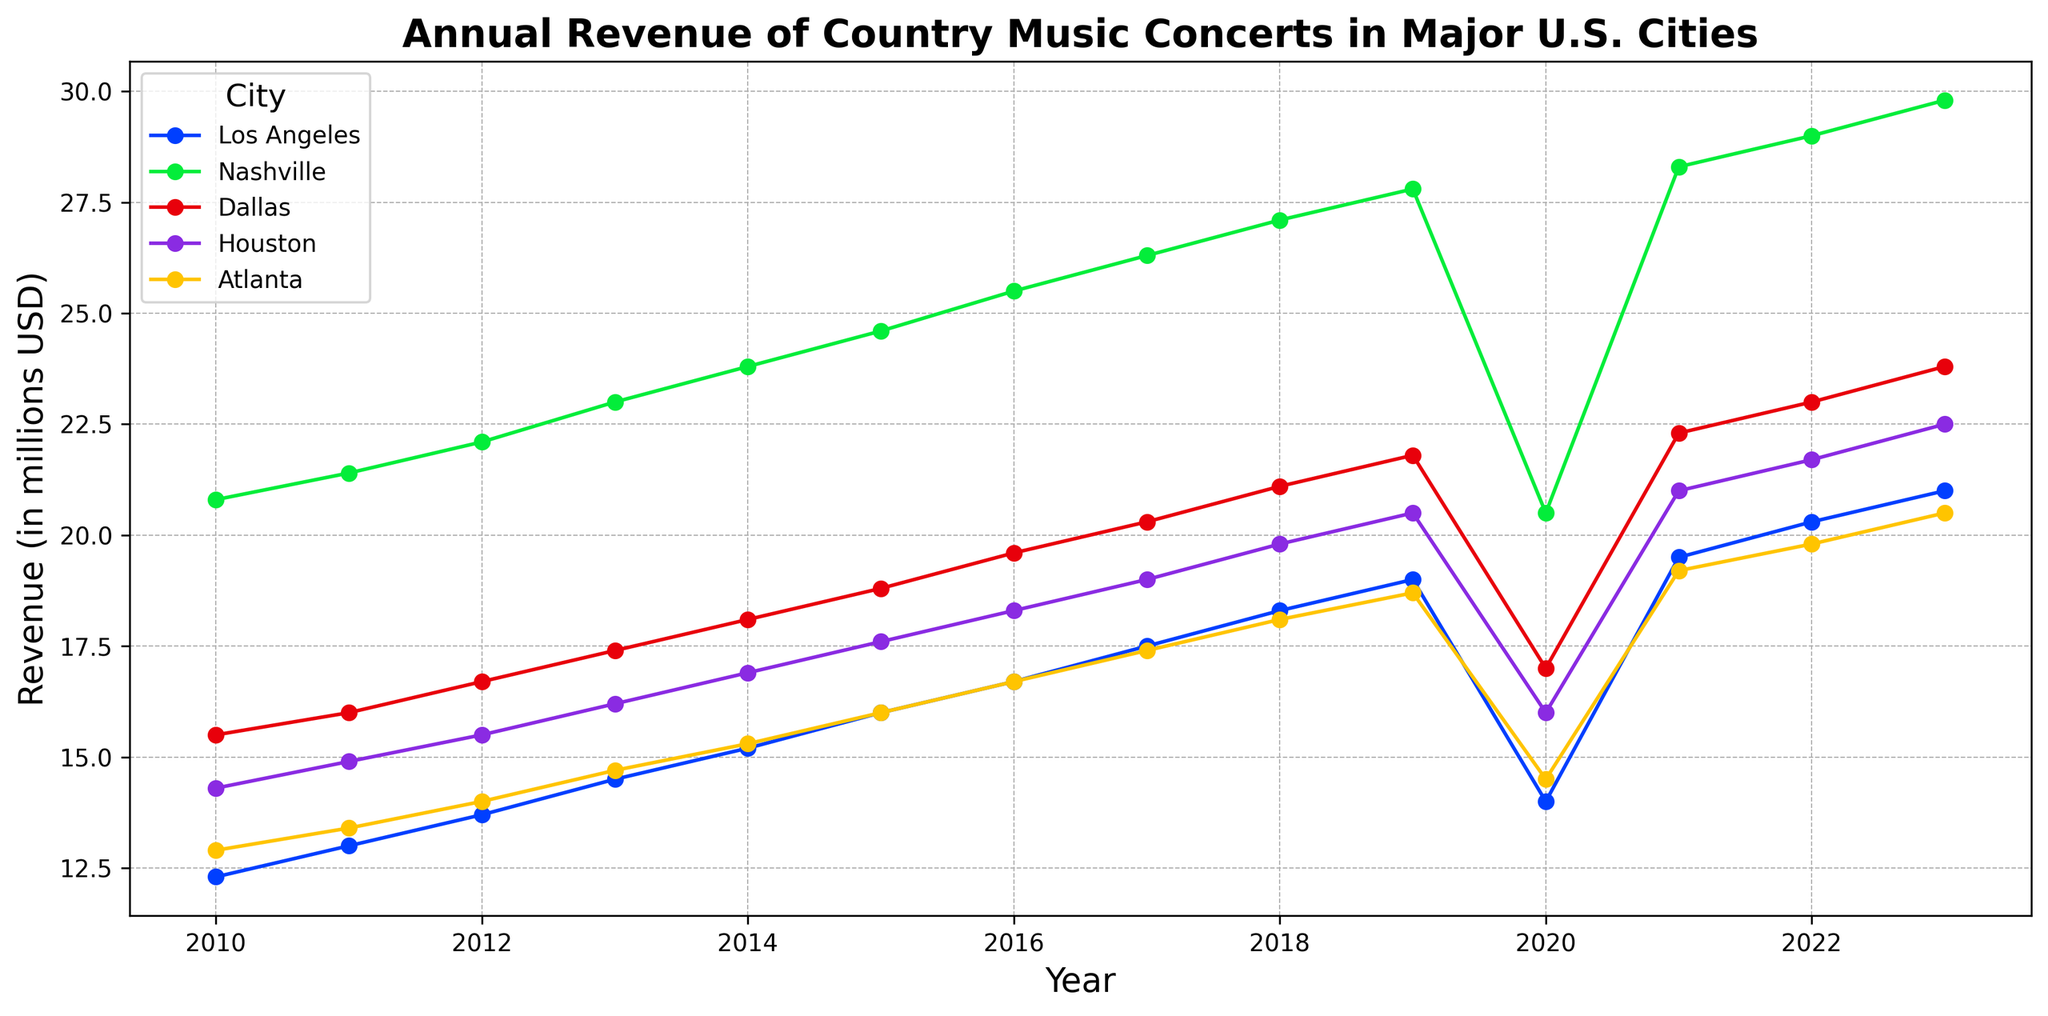What's the trend of annual revenue of country music concerts in Los Angeles from 2010 to 2023? The line for Los Angeles shows a general upward trend with a significant drop in 2020, and then it rises again through 2023.
Answer: Upward Which city had the highest annual revenue in 2023? In 2023, the line representing Nashville is the highest among all the cities.
Answer: Nashville How did the annual revenue of country music concerts in Los Angeles change from 2019 to 2020? Between 2019 and 2020, the line for Los Angeles shows a steep decline. The revenue dropped from 19.0 million USD in 2019 to 14.0 million USD in 2020.
Answer: Decreased Compare the annual revenue changes in Dallas and Houston from 2020 to 2022. From 2020 to 2022, Dallas's revenue increased from 17.0 to 23.0 million USD, while Houston's revenue increased from 16.0 to 21.7 million USD. Both cities show a positive growth, but Dallas's growth is larger.
Answer: Both increased, Dallas more What is the average annual revenue of country music concerts in Nashville from 2010 to 2013? Nashville's revenues for the years 2010 to 2013 are 20.8, 21.4, 22.1, and 23.0 million USD. The average is (20.8 + 21.4 + 22.1 + 23.0)/4 = 21.825 million USD.
Answer: 21.825 million USD Which city saw the largest revenue drop in 2020, and by how much? By observing the decline from 2019 to 2020 for each city, Los Angeles had the largest drop, going from 19.0 to 14.0 million USD, a drop of 5.0 million USD.
Answer: Los Angeles, 5.0 million USD What proportion of total revenue among the five cities did Los Angeles constitute in 2023? The total revenue in 2023 for all cities is the sum of the revenues: 21.0 (LA) + 29.8 (Nashville) + 23.8 (Dallas) + 22.5 (Houston) + 20.5 (Atlanta) = 117.6. The proportion for LA is 21.0 / 117.6 ≈ 0.178.
Answer: ~17.8% Between which consecutive years did Atlanta see its highest revenue growth? The line for Atlanta shows the highest increase between 2020 and 2021, where the revenue went from 14.5 to 19.2 million USD.
Answer: 2020 to 2021 If you compare the revenue patterns of Los Angeles and Nashville, what difference do you notice most prominently? Both cities show an increasing trend, but the revenue for Nashville is consistently higher than Los Angeles. The most prominent difference is the larger spike and peak values in Nashville compared to the steadier rise in Los Angeles.
Answer: Nashville consistently higher with larger spikes 